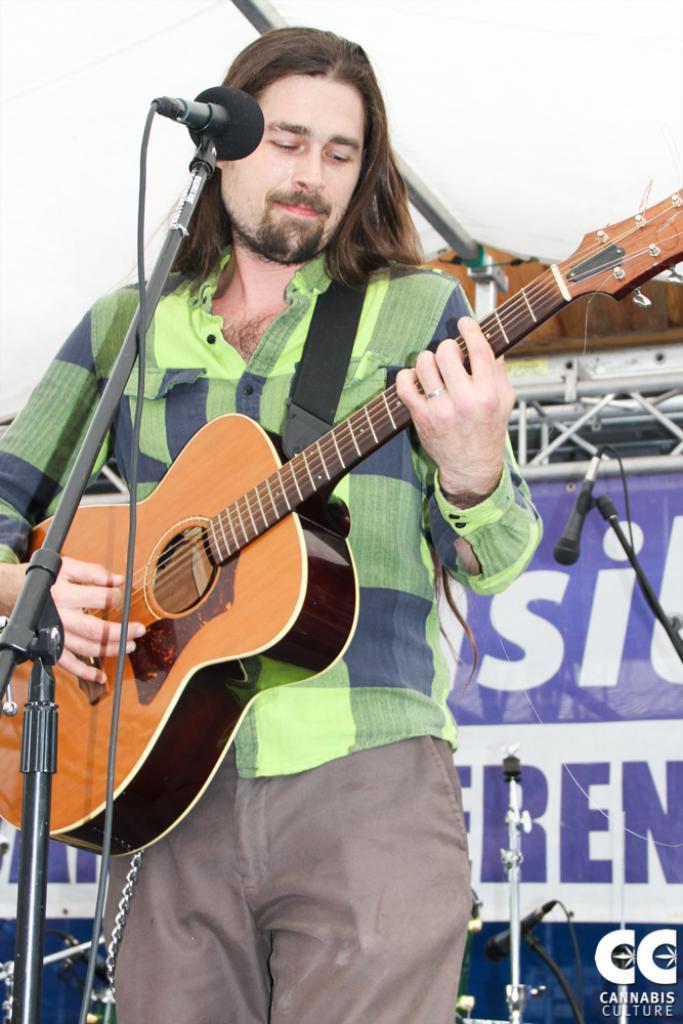Can you describe this image briefly? In this image, there is a man he is standing and holding a music instrument which is in yellow color, in the left side there is a microphone which is in black color, in the background there are some microphones which are in black color, there is a poster which is in blue color. 